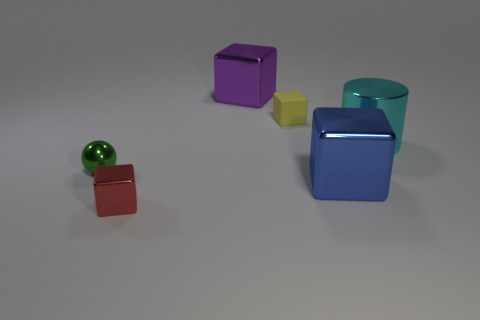What is the material of the other red thing that is the same shape as the rubber object?
Provide a succinct answer. Metal. There is a tiny red shiny object; does it have the same shape as the big thing that is on the left side of the big blue block?
Offer a very short reply. Yes. What number of green balls are in front of the small green object?
Keep it short and to the point. 0. Is there a green ball of the same size as the red thing?
Your answer should be very brief. Yes. Is the shape of the small thing to the right of the red metallic object the same as  the purple object?
Your answer should be very brief. Yes. What is the color of the metal ball?
Offer a very short reply. Green. Are any cyan shiny cylinders visible?
Keep it short and to the point. Yes. The purple thing that is the same material as the cyan object is what size?
Your answer should be very brief. Large. What is the shape of the big metallic thing that is right of the metal cube that is to the right of the large metal block that is on the left side of the tiny yellow matte cube?
Ensure brevity in your answer.  Cylinder. Are there the same number of tiny red objects that are right of the big blue thing and small blue matte blocks?
Your response must be concise. Yes. 